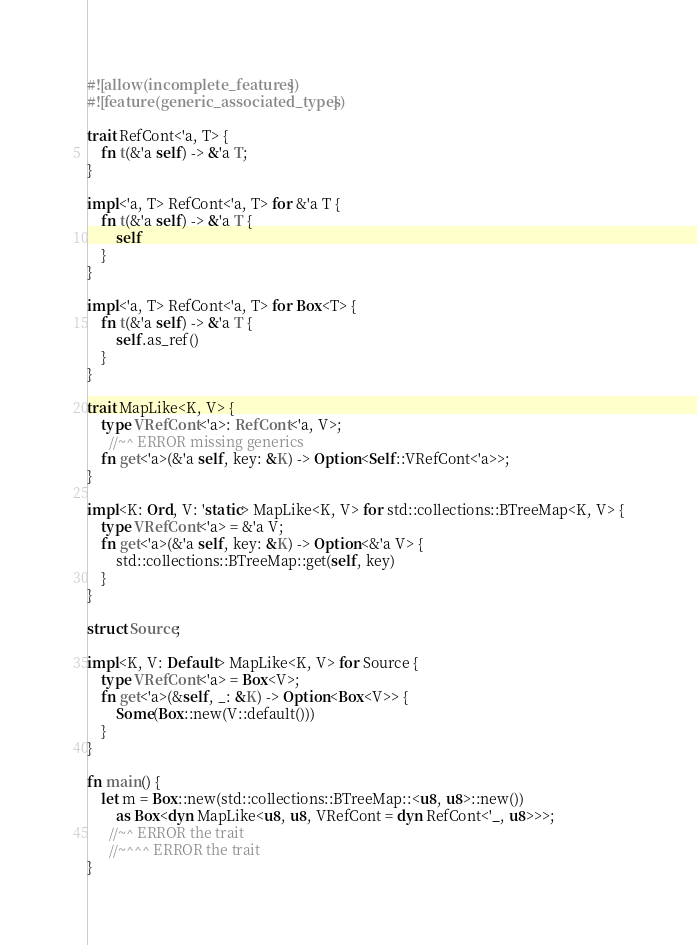<code> <loc_0><loc_0><loc_500><loc_500><_Rust_>#![allow(incomplete_features)]
#![feature(generic_associated_types)]

trait RefCont<'a, T> {
    fn t(&'a self) -> &'a T;
}

impl<'a, T> RefCont<'a, T> for &'a T {
    fn t(&'a self) -> &'a T {
        self
    }
}

impl<'a, T> RefCont<'a, T> for Box<T> {
    fn t(&'a self) -> &'a T {
        self.as_ref()
    }
}

trait MapLike<K, V> {
    type VRefCont<'a>: RefCont<'a, V>;
      //~^ ERROR missing generics
    fn get<'a>(&'a self, key: &K) -> Option<Self::VRefCont<'a>>;
}

impl<K: Ord, V: 'static> MapLike<K, V> for std::collections::BTreeMap<K, V> {
    type VRefCont<'a> = &'a V;
    fn get<'a>(&'a self, key: &K) -> Option<&'a V> {
        std::collections::BTreeMap::get(self, key)
    }
}

struct Source;

impl<K, V: Default> MapLike<K, V> for Source {
    type VRefCont<'a> = Box<V>;
    fn get<'a>(&self, _: &K) -> Option<Box<V>> {
        Some(Box::new(V::default()))
    }
}

fn main() {
    let m = Box::new(std::collections::BTreeMap::<u8, u8>::new())
        as Box<dyn MapLike<u8, u8, VRefCont = dyn RefCont<'_, u8>>>;
      //~^ ERROR the trait
      //~^^^ ERROR the trait
}
</code> 